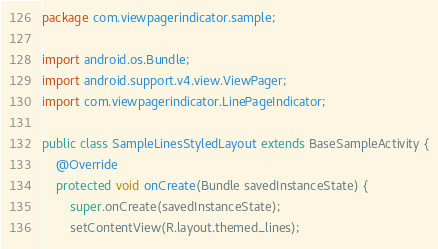Convert code to text. <code><loc_0><loc_0><loc_500><loc_500><_Java_>package com.viewpagerindicator.sample;

import android.os.Bundle;
import android.support.v4.view.ViewPager;
import com.viewpagerindicator.LinePageIndicator;

public class SampleLinesStyledLayout extends BaseSampleActivity {
    @Override
    protected void onCreate(Bundle savedInstanceState) {
        super.onCreate(savedInstanceState);
        setContentView(R.layout.themed_lines);
</code> 